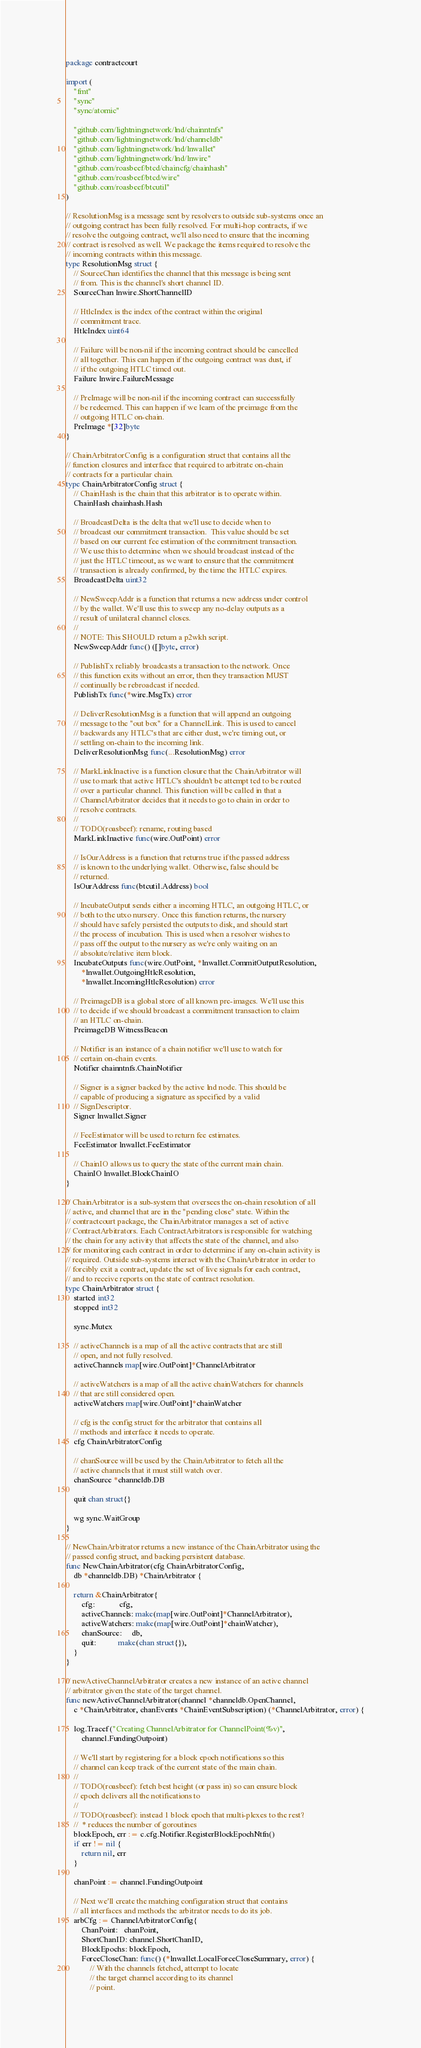<code> <loc_0><loc_0><loc_500><loc_500><_Go_>package contractcourt

import (
	"fmt"
	"sync"
	"sync/atomic"

	"github.com/lightningnetwork/lnd/chainntnfs"
	"github.com/lightningnetwork/lnd/channeldb"
	"github.com/lightningnetwork/lnd/lnwallet"
	"github.com/lightningnetwork/lnd/lnwire"
	"github.com/roasbeef/btcd/chaincfg/chainhash"
	"github.com/roasbeef/btcd/wire"
	"github.com/roasbeef/btcutil"
)

// ResolutionMsg is a message sent by resolvers to outside sub-systems once an
// outgoing contract has been fully resolved. For multi-hop contracts, if we
// resolve the outgoing contract, we'll also need to ensure that the incoming
// contract is resolved as well. We package the items required to resolve the
// incoming contracts within this message.
type ResolutionMsg struct {
	// SourceChan identifies the channel that this message is being sent
	// from. This is the channel's short channel ID.
	SourceChan lnwire.ShortChannelID

	// HtlcIndex is the index of the contract within the original
	// commitment trace.
	HtlcIndex uint64

	// Failure will be non-nil if the incoming contract should be cancelled
	// all together. This can happen if the outgoing contract was dust, if
	// if the outgoing HTLC timed out.
	Failure lnwire.FailureMessage

	// PreImage will be non-nil if the incoming contract can successfully
	// be redeemed. This can happen if we learn of the preimage from the
	// outgoing HTLC on-chain.
	PreImage *[32]byte
}

// ChainArbitratorConfig is a configuration struct that contains all the
// function closures and interface that required to arbitrate on-chain
// contracts for a particular chain.
type ChainArbitratorConfig struct {
	// ChainHash is the chain that this arbitrator is to operate within.
	ChainHash chainhash.Hash

	// BroadcastDelta is the delta that we'll use to decide when to
	// broadcast our commitment transaction.  This value should be set
	// based on our current fee estimation of the commitment transaction.
	// We use this to determine when we should broadcast instead of the
	// just the HTLC timeout, as we want to ensure that the commitment
	// transaction is already confirmed, by the time the HTLC expires.
	BroadcastDelta uint32

	// NewSweepAddr is a function that returns a new address under control
	// by the wallet. We'll use this to sweep any no-delay outputs as a
	// result of unilateral channel closes.
	//
	// NOTE: This SHOULD return a p2wkh script.
	NewSweepAddr func() ([]byte, error)

	// PublishTx reliably broadcasts a transaction to the network. Once
	// this function exits without an error, then they transaction MUST
	// continually be rebroadcast if needed.
	PublishTx func(*wire.MsgTx) error

	// DeliverResolutionMsg is a function that will append an outgoing
	// message to the "out box" for a ChannelLink. This is used to cancel
	// backwards any HTLC's that are either dust, we're timing out, or
	// settling on-chain to the incoming link.
	DeliverResolutionMsg func(...ResolutionMsg) error

	// MarkLinkInactive is a function closure that the ChainArbitrator will
	// use to mark that active HTLC's shouldn't be attempt ted to be routed
	// over a particular channel. This function will be called in that a
	// ChannelArbitrator decides that it needs to go to chain in order to
	// resolve contracts.
	//
	// TODO(roasbeef): rename, routing based
	MarkLinkInactive func(wire.OutPoint) error

	// IsOurAddress is a function that returns true if the passed address
	// is known to the underlying wallet. Otherwise, false should be
	// returned.
	IsOurAddress func(btcutil.Address) bool

	// IncubateOutput sends either a incoming HTLC, an outgoing HTLC, or
	// both to the utxo nursery. Once this function returns, the nursery
	// should have safely persisted the outputs to disk, and should start
	// the process of incubation. This is used when a resolver wishes to
	// pass off the output to the nursery as we're only waiting on an
	// absolute/relative item block.
	IncubateOutputs func(wire.OutPoint, *lnwallet.CommitOutputResolution,
		*lnwallet.OutgoingHtlcResolution,
		*lnwallet.IncomingHtlcResolution) error

	// PreimageDB is a global store of all known pre-images. We'll use this
	// to decide if we should broadcast a commitment transaction to claim
	// an HTLC on-chain.
	PreimageDB WitnessBeacon

	// Notifier is an instance of a chain notifier we'll use to watch for
	// certain on-chain events.
	Notifier chainntnfs.ChainNotifier

	// Signer is a signer backed by the active lnd node. This should be
	// capable of producing a signature as specified by a valid
	// SignDescriptor.
	Signer lnwallet.Signer

	// FeeEstimator will be used to return fee estimates.
	FeeEstimator lnwallet.FeeEstimator

	// ChainIO allows us to query the state of the current main chain.
	ChainIO lnwallet.BlockChainIO
}

// ChainArbitrator is a sub-system that oversees the on-chain resolution of all
// active, and channel that are in the "pending close" state. Within the
// contractcourt package, the ChainArbitrator manages a set of active
// ContractArbitrators. Each ContractArbitrators is responsible for watching
// the chain for any activity that affects the state of the channel, and also
// for monitoring each contract in order to determine if any on-chain activity is
// required. Outside sub-systems interact with the ChainArbitrator in order to
// forcibly exit a contract, update the set of live signals for each contract,
// and to receive reports on the state of contract resolution.
type ChainArbitrator struct {
	started int32
	stopped int32

	sync.Mutex

	// activeChannels is a map of all the active contracts that are still
	// open, and not fully resolved.
	activeChannels map[wire.OutPoint]*ChannelArbitrator

	// activeWatchers is a map of all the active chainWatchers for channels
	// that are still considered open.
	activeWatchers map[wire.OutPoint]*chainWatcher

	// cfg is the config struct for the arbitrator that contains all
	// methods and interface it needs to operate.
	cfg ChainArbitratorConfig

	// chanSource will be used by the ChainArbitrator to fetch all the
	// active channels that it must still watch over.
	chanSource *channeldb.DB

	quit chan struct{}

	wg sync.WaitGroup
}

// NewChainArbitrator returns a new instance of the ChainArbitrator using the
// passed config struct, and backing persistent database.
func NewChainArbitrator(cfg ChainArbitratorConfig,
	db *channeldb.DB) *ChainArbitrator {

	return &ChainArbitrator{
		cfg:            cfg,
		activeChannels: make(map[wire.OutPoint]*ChannelArbitrator),
		activeWatchers: make(map[wire.OutPoint]*chainWatcher),
		chanSource:     db,
		quit:           make(chan struct{}),
	}
}

// newActiveChannelArbitrator creates a new instance of an active channel
// arbitrator given the state of the target channel.
func newActiveChannelArbitrator(channel *channeldb.OpenChannel,
	c *ChainArbitrator, chanEvents *ChainEventSubscription) (*ChannelArbitrator, error) {

	log.Tracef("Creating ChannelArbitrator for ChannelPoint(%v)",
		channel.FundingOutpoint)

	// We'll start by registering for a block epoch notifications so this
	// channel can keep track of the current state of the main chain.
	//
	// TODO(roasbeef): fetch best height (or pass in) so can ensure block
	// epoch delivers all the notifications to
	//
	// TODO(roasbeef): instead 1 block epoch that multi-plexes to the rest?
	//  * reduces the number of goroutines
	blockEpoch, err := c.cfg.Notifier.RegisterBlockEpochNtfn()
	if err != nil {
		return nil, err
	}

	chanPoint := channel.FundingOutpoint

	// Next we'll create the matching configuration struct that contains
	// all interfaces and methods the arbitrator needs to do its job.
	arbCfg := ChannelArbitratorConfig{
		ChanPoint:   chanPoint,
		ShortChanID: channel.ShortChanID,
		BlockEpochs: blockEpoch,
		ForceCloseChan: func() (*lnwallet.LocalForceCloseSummary, error) {
			// With the channels fetched, attempt to locate
			// the target channel according to its channel
			// point.</code> 